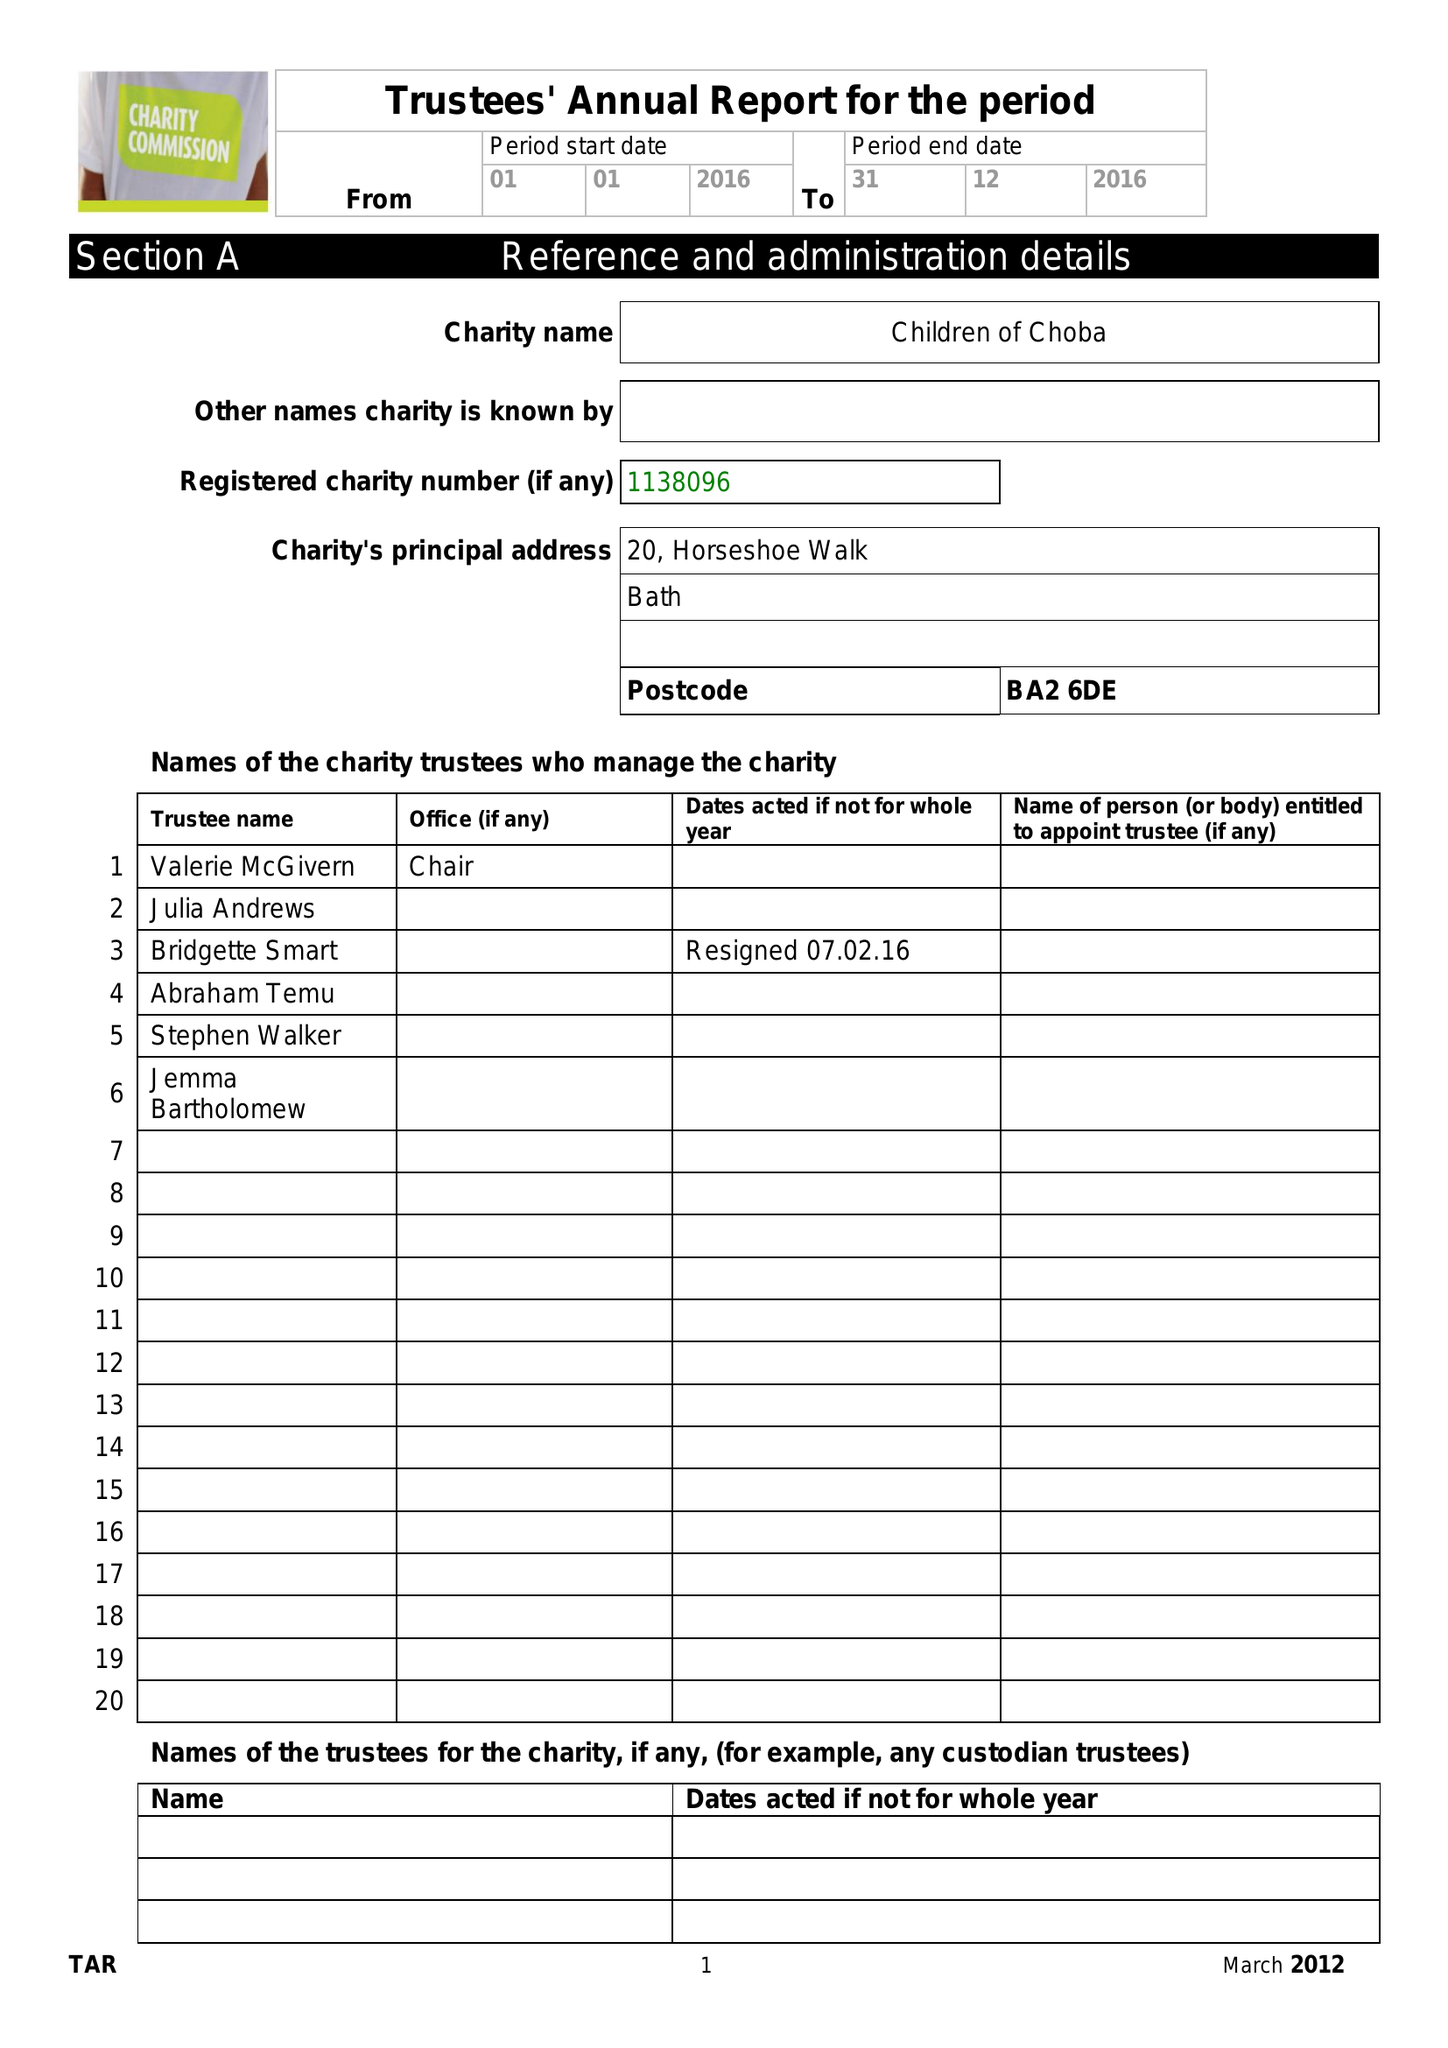What is the value for the charity_number?
Answer the question using a single word or phrase. 1138096 